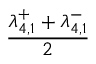<formula> <loc_0><loc_0><loc_500><loc_500>\frac { \lambda _ { 4 , 1 } ^ { + } + \lambda _ { 4 , 1 } ^ { - } } { 2 }</formula> 